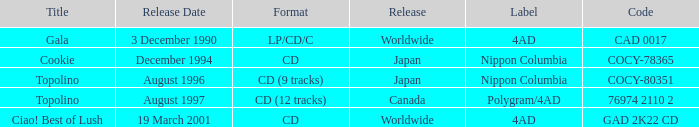Which format made its debut in august 1996? CD (9 tracks). 